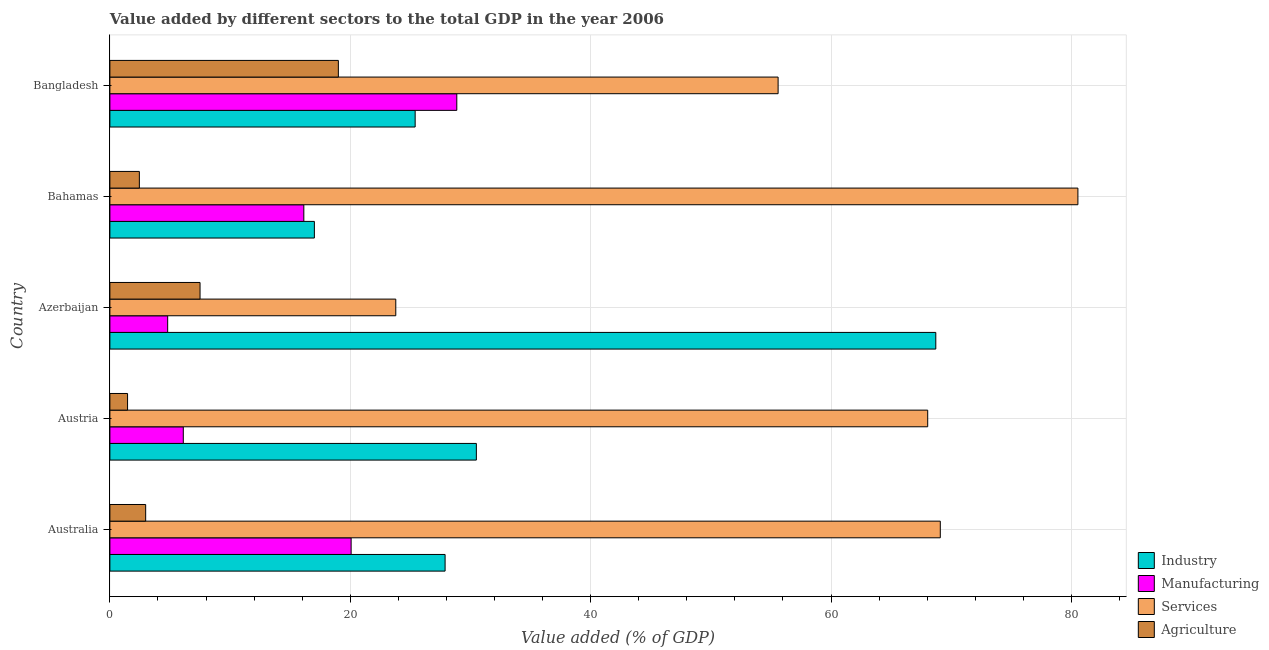How many different coloured bars are there?
Keep it short and to the point. 4. How many groups of bars are there?
Ensure brevity in your answer.  5. How many bars are there on the 4th tick from the top?
Provide a succinct answer. 4. In how many cases, is the number of bars for a given country not equal to the number of legend labels?
Your answer should be compact. 0. What is the value added by services sector in Azerbaijan?
Give a very brief answer. 23.79. Across all countries, what is the maximum value added by manufacturing sector?
Give a very brief answer. 28.86. Across all countries, what is the minimum value added by manufacturing sector?
Ensure brevity in your answer.  4.81. In which country was the value added by industrial sector maximum?
Your response must be concise. Azerbaijan. In which country was the value added by industrial sector minimum?
Offer a very short reply. Bahamas. What is the total value added by services sector in the graph?
Offer a very short reply. 297.04. What is the difference between the value added by services sector in Austria and that in Azerbaijan?
Offer a very short reply. 44.25. What is the difference between the value added by services sector in Australia and the value added by manufacturing sector in Austria?
Keep it short and to the point. 62.98. What is the average value added by agricultural sector per country?
Ensure brevity in your answer.  6.68. What is the difference between the value added by manufacturing sector and value added by services sector in Azerbaijan?
Your response must be concise. -18.98. What is the ratio of the value added by services sector in Australia to that in Azerbaijan?
Offer a terse response. 2.9. Is the difference between the value added by services sector in Australia and Azerbaijan greater than the difference between the value added by manufacturing sector in Australia and Azerbaijan?
Ensure brevity in your answer.  Yes. What is the difference between the highest and the second highest value added by industrial sector?
Provide a short and direct response. 38.22. What is the difference between the highest and the lowest value added by manufacturing sector?
Keep it short and to the point. 24.05. In how many countries, is the value added by agricultural sector greater than the average value added by agricultural sector taken over all countries?
Ensure brevity in your answer.  2. What does the 1st bar from the top in Bahamas represents?
Ensure brevity in your answer.  Agriculture. What does the 3rd bar from the bottom in Australia represents?
Provide a succinct answer. Services. How many bars are there?
Provide a succinct answer. 20. Are all the bars in the graph horizontal?
Ensure brevity in your answer.  Yes. What is the difference between two consecutive major ticks on the X-axis?
Offer a very short reply. 20. How are the legend labels stacked?
Keep it short and to the point. Vertical. What is the title of the graph?
Offer a terse response. Value added by different sectors to the total GDP in the year 2006. What is the label or title of the X-axis?
Offer a very short reply. Value added (% of GDP). What is the Value added (% of GDP) in Industry in Australia?
Provide a short and direct response. 27.89. What is the Value added (% of GDP) of Manufacturing in Australia?
Make the answer very short. 20.07. What is the Value added (% of GDP) in Services in Australia?
Offer a very short reply. 69.09. What is the Value added (% of GDP) of Agriculture in Australia?
Make the answer very short. 2.98. What is the Value added (% of GDP) in Industry in Austria?
Offer a very short reply. 30.49. What is the Value added (% of GDP) of Manufacturing in Austria?
Keep it short and to the point. 6.11. What is the Value added (% of GDP) in Services in Austria?
Offer a terse response. 68.04. What is the Value added (% of GDP) of Agriculture in Austria?
Your answer should be very brief. 1.47. What is the Value added (% of GDP) of Industry in Azerbaijan?
Offer a very short reply. 68.71. What is the Value added (% of GDP) of Manufacturing in Azerbaijan?
Make the answer very short. 4.81. What is the Value added (% of GDP) of Services in Azerbaijan?
Ensure brevity in your answer.  23.79. What is the Value added (% of GDP) of Agriculture in Azerbaijan?
Your response must be concise. 7.5. What is the Value added (% of GDP) in Industry in Bahamas?
Offer a terse response. 17.01. What is the Value added (% of GDP) in Manufacturing in Bahamas?
Offer a terse response. 16.13. What is the Value added (% of GDP) of Services in Bahamas?
Your answer should be very brief. 80.54. What is the Value added (% of GDP) of Agriculture in Bahamas?
Your response must be concise. 2.45. What is the Value added (% of GDP) in Industry in Bangladesh?
Offer a terse response. 25.4. What is the Value added (% of GDP) of Manufacturing in Bangladesh?
Provide a succinct answer. 28.86. What is the Value added (% of GDP) of Services in Bangladesh?
Give a very brief answer. 55.59. What is the Value added (% of GDP) of Agriculture in Bangladesh?
Your answer should be very brief. 19.01. Across all countries, what is the maximum Value added (% of GDP) of Industry?
Offer a very short reply. 68.71. Across all countries, what is the maximum Value added (% of GDP) of Manufacturing?
Make the answer very short. 28.86. Across all countries, what is the maximum Value added (% of GDP) of Services?
Keep it short and to the point. 80.54. Across all countries, what is the maximum Value added (% of GDP) of Agriculture?
Provide a short and direct response. 19.01. Across all countries, what is the minimum Value added (% of GDP) of Industry?
Your answer should be very brief. 17.01. Across all countries, what is the minimum Value added (% of GDP) of Manufacturing?
Give a very brief answer. 4.81. Across all countries, what is the minimum Value added (% of GDP) of Services?
Your answer should be compact. 23.79. Across all countries, what is the minimum Value added (% of GDP) in Agriculture?
Offer a very short reply. 1.47. What is the total Value added (% of GDP) in Industry in the graph?
Offer a very short reply. 169.5. What is the total Value added (% of GDP) in Manufacturing in the graph?
Provide a short and direct response. 75.98. What is the total Value added (% of GDP) of Services in the graph?
Your answer should be compact. 297.04. What is the total Value added (% of GDP) in Agriculture in the graph?
Provide a succinct answer. 33.41. What is the difference between the Value added (% of GDP) in Industry in Australia and that in Austria?
Make the answer very short. -2.6. What is the difference between the Value added (% of GDP) in Manufacturing in Australia and that in Austria?
Keep it short and to the point. 13.96. What is the difference between the Value added (% of GDP) of Services in Australia and that in Austria?
Make the answer very short. 1.05. What is the difference between the Value added (% of GDP) of Agriculture in Australia and that in Austria?
Make the answer very short. 1.51. What is the difference between the Value added (% of GDP) of Industry in Australia and that in Azerbaijan?
Give a very brief answer. -40.83. What is the difference between the Value added (% of GDP) in Manufacturing in Australia and that in Azerbaijan?
Offer a terse response. 15.26. What is the difference between the Value added (% of GDP) in Services in Australia and that in Azerbaijan?
Ensure brevity in your answer.  45.3. What is the difference between the Value added (% of GDP) in Agriculture in Australia and that in Azerbaijan?
Make the answer very short. -4.52. What is the difference between the Value added (% of GDP) in Industry in Australia and that in Bahamas?
Offer a very short reply. 10.88. What is the difference between the Value added (% of GDP) of Manufacturing in Australia and that in Bahamas?
Provide a short and direct response. 3.94. What is the difference between the Value added (% of GDP) in Services in Australia and that in Bahamas?
Keep it short and to the point. -11.45. What is the difference between the Value added (% of GDP) of Agriculture in Australia and that in Bahamas?
Give a very brief answer. 0.52. What is the difference between the Value added (% of GDP) of Industry in Australia and that in Bangladesh?
Provide a succinct answer. 2.49. What is the difference between the Value added (% of GDP) of Manufacturing in Australia and that in Bangladesh?
Provide a succinct answer. -8.79. What is the difference between the Value added (% of GDP) of Services in Australia and that in Bangladesh?
Make the answer very short. 13.49. What is the difference between the Value added (% of GDP) of Agriculture in Australia and that in Bangladesh?
Your response must be concise. -16.03. What is the difference between the Value added (% of GDP) of Industry in Austria and that in Azerbaijan?
Give a very brief answer. -38.22. What is the difference between the Value added (% of GDP) of Manufacturing in Austria and that in Azerbaijan?
Ensure brevity in your answer.  1.3. What is the difference between the Value added (% of GDP) in Services in Austria and that in Azerbaijan?
Offer a very short reply. 44.25. What is the difference between the Value added (% of GDP) of Agriculture in Austria and that in Azerbaijan?
Your response must be concise. -6.03. What is the difference between the Value added (% of GDP) of Industry in Austria and that in Bahamas?
Your answer should be very brief. 13.48. What is the difference between the Value added (% of GDP) of Manufacturing in Austria and that in Bahamas?
Offer a terse response. -10.03. What is the difference between the Value added (% of GDP) in Services in Austria and that in Bahamas?
Make the answer very short. -12.5. What is the difference between the Value added (% of GDP) of Agriculture in Austria and that in Bahamas?
Your answer should be very brief. -0.98. What is the difference between the Value added (% of GDP) in Industry in Austria and that in Bangladesh?
Offer a very short reply. 5.09. What is the difference between the Value added (% of GDP) in Manufacturing in Austria and that in Bangladesh?
Offer a terse response. -22.75. What is the difference between the Value added (% of GDP) in Services in Austria and that in Bangladesh?
Your answer should be very brief. 12.45. What is the difference between the Value added (% of GDP) in Agriculture in Austria and that in Bangladesh?
Your response must be concise. -17.54. What is the difference between the Value added (% of GDP) in Industry in Azerbaijan and that in Bahamas?
Offer a very short reply. 51.7. What is the difference between the Value added (% of GDP) in Manufacturing in Azerbaijan and that in Bahamas?
Provide a short and direct response. -11.33. What is the difference between the Value added (% of GDP) in Services in Azerbaijan and that in Bahamas?
Your answer should be compact. -56.75. What is the difference between the Value added (% of GDP) of Agriculture in Azerbaijan and that in Bahamas?
Keep it short and to the point. 5.05. What is the difference between the Value added (% of GDP) of Industry in Azerbaijan and that in Bangladesh?
Your response must be concise. 43.32. What is the difference between the Value added (% of GDP) in Manufacturing in Azerbaijan and that in Bangladesh?
Give a very brief answer. -24.05. What is the difference between the Value added (% of GDP) of Services in Azerbaijan and that in Bangladesh?
Your response must be concise. -31.81. What is the difference between the Value added (% of GDP) of Agriculture in Azerbaijan and that in Bangladesh?
Keep it short and to the point. -11.51. What is the difference between the Value added (% of GDP) in Industry in Bahamas and that in Bangladesh?
Provide a succinct answer. -8.39. What is the difference between the Value added (% of GDP) of Manufacturing in Bahamas and that in Bangladesh?
Ensure brevity in your answer.  -12.73. What is the difference between the Value added (% of GDP) of Services in Bahamas and that in Bangladesh?
Offer a terse response. 24.94. What is the difference between the Value added (% of GDP) of Agriculture in Bahamas and that in Bangladesh?
Your answer should be compact. -16.56. What is the difference between the Value added (% of GDP) of Industry in Australia and the Value added (% of GDP) of Manufacturing in Austria?
Provide a short and direct response. 21.78. What is the difference between the Value added (% of GDP) of Industry in Australia and the Value added (% of GDP) of Services in Austria?
Offer a very short reply. -40.15. What is the difference between the Value added (% of GDP) in Industry in Australia and the Value added (% of GDP) in Agriculture in Austria?
Your response must be concise. 26.42. What is the difference between the Value added (% of GDP) of Manufacturing in Australia and the Value added (% of GDP) of Services in Austria?
Keep it short and to the point. -47.97. What is the difference between the Value added (% of GDP) in Manufacturing in Australia and the Value added (% of GDP) in Agriculture in Austria?
Provide a succinct answer. 18.6. What is the difference between the Value added (% of GDP) in Services in Australia and the Value added (% of GDP) in Agriculture in Austria?
Provide a succinct answer. 67.62. What is the difference between the Value added (% of GDP) of Industry in Australia and the Value added (% of GDP) of Manufacturing in Azerbaijan?
Offer a terse response. 23.08. What is the difference between the Value added (% of GDP) in Industry in Australia and the Value added (% of GDP) in Services in Azerbaijan?
Give a very brief answer. 4.1. What is the difference between the Value added (% of GDP) in Industry in Australia and the Value added (% of GDP) in Agriculture in Azerbaijan?
Offer a terse response. 20.39. What is the difference between the Value added (% of GDP) of Manufacturing in Australia and the Value added (% of GDP) of Services in Azerbaijan?
Keep it short and to the point. -3.72. What is the difference between the Value added (% of GDP) in Manufacturing in Australia and the Value added (% of GDP) in Agriculture in Azerbaijan?
Keep it short and to the point. 12.57. What is the difference between the Value added (% of GDP) in Services in Australia and the Value added (% of GDP) in Agriculture in Azerbaijan?
Offer a very short reply. 61.59. What is the difference between the Value added (% of GDP) in Industry in Australia and the Value added (% of GDP) in Manufacturing in Bahamas?
Provide a succinct answer. 11.75. What is the difference between the Value added (% of GDP) in Industry in Australia and the Value added (% of GDP) in Services in Bahamas?
Give a very brief answer. -52.65. What is the difference between the Value added (% of GDP) in Industry in Australia and the Value added (% of GDP) in Agriculture in Bahamas?
Your answer should be very brief. 25.44. What is the difference between the Value added (% of GDP) in Manufacturing in Australia and the Value added (% of GDP) in Services in Bahamas?
Provide a succinct answer. -60.47. What is the difference between the Value added (% of GDP) of Manufacturing in Australia and the Value added (% of GDP) of Agriculture in Bahamas?
Offer a very short reply. 17.62. What is the difference between the Value added (% of GDP) of Services in Australia and the Value added (% of GDP) of Agriculture in Bahamas?
Your answer should be very brief. 66.64. What is the difference between the Value added (% of GDP) in Industry in Australia and the Value added (% of GDP) in Manufacturing in Bangladesh?
Give a very brief answer. -0.97. What is the difference between the Value added (% of GDP) in Industry in Australia and the Value added (% of GDP) in Services in Bangladesh?
Your answer should be very brief. -27.71. What is the difference between the Value added (% of GDP) in Industry in Australia and the Value added (% of GDP) in Agriculture in Bangladesh?
Keep it short and to the point. 8.88. What is the difference between the Value added (% of GDP) in Manufacturing in Australia and the Value added (% of GDP) in Services in Bangladesh?
Your answer should be very brief. -35.52. What is the difference between the Value added (% of GDP) in Manufacturing in Australia and the Value added (% of GDP) in Agriculture in Bangladesh?
Ensure brevity in your answer.  1.06. What is the difference between the Value added (% of GDP) of Services in Australia and the Value added (% of GDP) of Agriculture in Bangladesh?
Your answer should be compact. 50.08. What is the difference between the Value added (% of GDP) of Industry in Austria and the Value added (% of GDP) of Manufacturing in Azerbaijan?
Offer a terse response. 25.68. What is the difference between the Value added (% of GDP) in Industry in Austria and the Value added (% of GDP) in Services in Azerbaijan?
Offer a terse response. 6.7. What is the difference between the Value added (% of GDP) of Industry in Austria and the Value added (% of GDP) of Agriculture in Azerbaijan?
Make the answer very short. 22.99. What is the difference between the Value added (% of GDP) in Manufacturing in Austria and the Value added (% of GDP) in Services in Azerbaijan?
Ensure brevity in your answer.  -17.68. What is the difference between the Value added (% of GDP) in Manufacturing in Austria and the Value added (% of GDP) in Agriculture in Azerbaijan?
Offer a terse response. -1.39. What is the difference between the Value added (% of GDP) in Services in Austria and the Value added (% of GDP) in Agriculture in Azerbaijan?
Offer a very short reply. 60.54. What is the difference between the Value added (% of GDP) of Industry in Austria and the Value added (% of GDP) of Manufacturing in Bahamas?
Your answer should be compact. 14.36. What is the difference between the Value added (% of GDP) in Industry in Austria and the Value added (% of GDP) in Services in Bahamas?
Your answer should be very brief. -50.05. What is the difference between the Value added (% of GDP) of Industry in Austria and the Value added (% of GDP) of Agriculture in Bahamas?
Ensure brevity in your answer.  28.04. What is the difference between the Value added (% of GDP) in Manufacturing in Austria and the Value added (% of GDP) in Services in Bahamas?
Keep it short and to the point. -74.43. What is the difference between the Value added (% of GDP) of Manufacturing in Austria and the Value added (% of GDP) of Agriculture in Bahamas?
Make the answer very short. 3.66. What is the difference between the Value added (% of GDP) in Services in Austria and the Value added (% of GDP) in Agriculture in Bahamas?
Ensure brevity in your answer.  65.59. What is the difference between the Value added (% of GDP) of Industry in Austria and the Value added (% of GDP) of Manufacturing in Bangladesh?
Your answer should be compact. 1.63. What is the difference between the Value added (% of GDP) of Industry in Austria and the Value added (% of GDP) of Services in Bangladesh?
Offer a very short reply. -25.1. What is the difference between the Value added (% of GDP) in Industry in Austria and the Value added (% of GDP) in Agriculture in Bangladesh?
Offer a very short reply. 11.48. What is the difference between the Value added (% of GDP) in Manufacturing in Austria and the Value added (% of GDP) in Services in Bangladesh?
Provide a short and direct response. -49.49. What is the difference between the Value added (% of GDP) in Manufacturing in Austria and the Value added (% of GDP) in Agriculture in Bangladesh?
Offer a very short reply. -12.9. What is the difference between the Value added (% of GDP) of Services in Austria and the Value added (% of GDP) of Agriculture in Bangladesh?
Offer a terse response. 49.03. What is the difference between the Value added (% of GDP) in Industry in Azerbaijan and the Value added (% of GDP) in Manufacturing in Bahamas?
Your answer should be very brief. 52.58. What is the difference between the Value added (% of GDP) in Industry in Azerbaijan and the Value added (% of GDP) in Services in Bahamas?
Give a very brief answer. -11.82. What is the difference between the Value added (% of GDP) in Industry in Azerbaijan and the Value added (% of GDP) in Agriculture in Bahamas?
Ensure brevity in your answer.  66.26. What is the difference between the Value added (% of GDP) in Manufacturing in Azerbaijan and the Value added (% of GDP) in Services in Bahamas?
Make the answer very short. -75.73. What is the difference between the Value added (% of GDP) in Manufacturing in Azerbaijan and the Value added (% of GDP) in Agriculture in Bahamas?
Your answer should be very brief. 2.36. What is the difference between the Value added (% of GDP) in Services in Azerbaijan and the Value added (% of GDP) in Agriculture in Bahamas?
Offer a very short reply. 21.33. What is the difference between the Value added (% of GDP) in Industry in Azerbaijan and the Value added (% of GDP) in Manufacturing in Bangladesh?
Your answer should be compact. 39.85. What is the difference between the Value added (% of GDP) of Industry in Azerbaijan and the Value added (% of GDP) of Services in Bangladesh?
Provide a succinct answer. 13.12. What is the difference between the Value added (% of GDP) in Industry in Azerbaijan and the Value added (% of GDP) in Agriculture in Bangladesh?
Your response must be concise. 49.7. What is the difference between the Value added (% of GDP) in Manufacturing in Azerbaijan and the Value added (% of GDP) in Services in Bangladesh?
Keep it short and to the point. -50.79. What is the difference between the Value added (% of GDP) in Manufacturing in Azerbaijan and the Value added (% of GDP) in Agriculture in Bangladesh?
Ensure brevity in your answer.  -14.2. What is the difference between the Value added (% of GDP) in Services in Azerbaijan and the Value added (% of GDP) in Agriculture in Bangladesh?
Offer a terse response. 4.78. What is the difference between the Value added (% of GDP) in Industry in Bahamas and the Value added (% of GDP) in Manufacturing in Bangladesh?
Provide a short and direct response. -11.85. What is the difference between the Value added (% of GDP) in Industry in Bahamas and the Value added (% of GDP) in Services in Bangladesh?
Give a very brief answer. -38.58. What is the difference between the Value added (% of GDP) in Industry in Bahamas and the Value added (% of GDP) in Agriculture in Bangladesh?
Keep it short and to the point. -2. What is the difference between the Value added (% of GDP) of Manufacturing in Bahamas and the Value added (% of GDP) of Services in Bangladesh?
Make the answer very short. -39.46. What is the difference between the Value added (% of GDP) of Manufacturing in Bahamas and the Value added (% of GDP) of Agriculture in Bangladesh?
Offer a very short reply. -2.87. What is the difference between the Value added (% of GDP) of Services in Bahamas and the Value added (% of GDP) of Agriculture in Bangladesh?
Keep it short and to the point. 61.53. What is the average Value added (% of GDP) in Industry per country?
Give a very brief answer. 33.9. What is the average Value added (% of GDP) in Manufacturing per country?
Make the answer very short. 15.2. What is the average Value added (% of GDP) in Services per country?
Give a very brief answer. 59.41. What is the average Value added (% of GDP) of Agriculture per country?
Offer a very short reply. 6.68. What is the difference between the Value added (% of GDP) of Industry and Value added (% of GDP) of Manufacturing in Australia?
Offer a very short reply. 7.82. What is the difference between the Value added (% of GDP) of Industry and Value added (% of GDP) of Services in Australia?
Your answer should be compact. -41.2. What is the difference between the Value added (% of GDP) of Industry and Value added (% of GDP) of Agriculture in Australia?
Offer a terse response. 24.91. What is the difference between the Value added (% of GDP) of Manufacturing and Value added (% of GDP) of Services in Australia?
Offer a terse response. -49.02. What is the difference between the Value added (% of GDP) of Manufacturing and Value added (% of GDP) of Agriculture in Australia?
Your response must be concise. 17.09. What is the difference between the Value added (% of GDP) in Services and Value added (% of GDP) in Agriculture in Australia?
Your response must be concise. 66.11. What is the difference between the Value added (% of GDP) in Industry and Value added (% of GDP) in Manufacturing in Austria?
Offer a terse response. 24.38. What is the difference between the Value added (% of GDP) in Industry and Value added (% of GDP) in Services in Austria?
Offer a very short reply. -37.55. What is the difference between the Value added (% of GDP) of Industry and Value added (% of GDP) of Agriculture in Austria?
Your answer should be compact. 29.02. What is the difference between the Value added (% of GDP) in Manufacturing and Value added (% of GDP) in Services in Austria?
Your answer should be very brief. -61.93. What is the difference between the Value added (% of GDP) of Manufacturing and Value added (% of GDP) of Agriculture in Austria?
Provide a succinct answer. 4.64. What is the difference between the Value added (% of GDP) in Services and Value added (% of GDP) in Agriculture in Austria?
Your response must be concise. 66.57. What is the difference between the Value added (% of GDP) of Industry and Value added (% of GDP) of Manufacturing in Azerbaijan?
Give a very brief answer. 63.91. What is the difference between the Value added (% of GDP) in Industry and Value added (% of GDP) in Services in Azerbaijan?
Ensure brevity in your answer.  44.93. What is the difference between the Value added (% of GDP) in Industry and Value added (% of GDP) in Agriculture in Azerbaijan?
Your answer should be very brief. 61.21. What is the difference between the Value added (% of GDP) in Manufacturing and Value added (% of GDP) in Services in Azerbaijan?
Keep it short and to the point. -18.98. What is the difference between the Value added (% of GDP) of Manufacturing and Value added (% of GDP) of Agriculture in Azerbaijan?
Give a very brief answer. -2.69. What is the difference between the Value added (% of GDP) of Services and Value added (% of GDP) of Agriculture in Azerbaijan?
Your answer should be compact. 16.29. What is the difference between the Value added (% of GDP) of Industry and Value added (% of GDP) of Manufacturing in Bahamas?
Your answer should be compact. 0.88. What is the difference between the Value added (% of GDP) of Industry and Value added (% of GDP) of Services in Bahamas?
Make the answer very short. -63.52. What is the difference between the Value added (% of GDP) in Industry and Value added (% of GDP) in Agriculture in Bahamas?
Provide a succinct answer. 14.56. What is the difference between the Value added (% of GDP) of Manufacturing and Value added (% of GDP) of Services in Bahamas?
Make the answer very short. -64.4. What is the difference between the Value added (% of GDP) of Manufacturing and Value added (% of GDP) of Agriculture in Bahamas?
Provide a succinct answer. 13.68. What is the difference between the Value added (% of GDP) of Services and Value added (% of GDP) of Agriculture in Bahamas?
Make the answer very short. 78.08. What is the difference between the Value added (% of GDP) of Industry and Value added (% of GDP) of Manufacturing in Bangladesh?
Provide a succinct answer. -3.46. What is the difference between the Value added (% of GDP) in Industry and Value added (% of GDP) in Services in Bangladesh?
Ensure brevity in your answer.  -30.2. What is the difference between the Value added (% of GDP) of Industry and Value added (% of GDP) of Agriculture in Bangladesh?
Ensure brevity in your answer.  6.39. What is the difference between the Value added (% of GDP) of Manufacturing and Value added (% of GDP) of Services in Bangladesh?
Your answer should be compact. -26.73. What is the difference between the Value added (% of GDP) in Manufacturing and Value added (% of GDP) in Agriculture in Bangladesh?
Provide a short and direct response. 9.85. What is the difference between the Value added (% of GDP) in Services and Value added (% of GDP) in Agriculture in Bangladesh?
Your answer should be very brief. 36.59. What is the ratio of the Value added (% of GDP) in Industry in Australia to that in Austria?
Provide a succinct answer. 0.91. What is the ratio of the Value added (% of GDP) in Manufacturing in Australia to that in Austria?
Your answer should be compact. 3.29. What is the ratio of the Value added (% of GDP) of Services in Australia to that in Austria?
Offer a terse response. 1.02. What is the ratio of the Value added (% of GDP) in Agriculture in Australia to that in Austria?
Your response must be concise. 2.02. What is the ratio of the Value added (% of GDP) in Industry in Australia to that in Azerbaijan?
Keep it short and to the point. 0.41. What is the ratio of the Value added (% of GDP) in Manufacturing in Australia to that in Azerbaijan?
Provide a succinct answer. 4.17. What is the ratio of the Value added (% of GDP) of Services in Australia to that in Azerbaijan?
Offer a very short reply. 2.9. What is the ratio of the Value added (% of GDP) of Agriculture in Australia to that in Azerbaijan?
Provide a succinct answer. 0.4. What is the ratio of the Value added (% of GDP) of Industry in Australia to that in Bahamas?
Give a very brief answer. 1.64. What is the ratio of the Value added (% of GDP) in Manufacturing in Australia to that in Bahamas?
Provide a short and direct response. 1.24. What is the ratio of the Value added (% of GDP) in Services in Australia to that in Bahamas?
Offer a very short reply. 0.86. What is the ratio of the Value added (% of GDP) in Agriculture in Australia to that in Bahamas?
Keep it short and to the point. 1.21. What is the ratio of the Value added (% of GDP) in Industry in Australia to that in Bangladesh?
Provide a short and direct response. 1.1. What is the ratio of the Value added (% of GDP) of Manufacturing in Australia to that in Bangladesh?
Provide a succinct answer. 0.7. What is the ratio of the Value added (% of GDP) of Services in Australia to that in Bangladesh?
Provide a succinct answer. 1.24. What is the ratio of the Value added (% of GDP) of Agriculture in Australia to that in Bangladesh?
Offer a terse response. 0.16. What is the ratio of the Value added (% of GDP) in Industry in Austria to that in Azerbaijan?
Give a very brief answer. 0.44. What is the ratio of the Value added (% of GDP) in Manufacturing in Austria to that in Azerbaijan?
Ensure brevity in your answer.  1.27. What is the ratio of the Value added (% of GDP) in Services in Austria to that in Azerbaijan?
Your response must be concise. 2.86. What is the ratio of the Value added (% of GDP) in Agriculture in Austria to that in Azerbaijan?
Your answer should be very brief. 0.2. What is the ratio of the Value added (% of GDP) in Industry in Austria to that in Bahamas?
Offer a terse response. 1.79. What is the ratio of the Value added (% of GDP) of Manufacturing in Austria to that in Bahamas?
Your response must be concise. 0.38. What is the ratio of the Value added (% of GDP) of Services in Austria to that in Bahamas?
Your response must be concise. 0.84. What is the ratio of the Value added (% of GDP) in Agriculture in Austria to that in Bahamas?
Ensure brevity in your answer.  0.6. What is the ratio of the Value added (% of GDP) of Industry in Austria to that in Bangladesh?
Offer a very short reply. 1.2. What is the ratio of the Value added (% of GDP) of Manufacturing in Austria to that in Bangladesh?
Offer a terse response. 0.21. What is the ratio of the Value added (% of GDP) of Services in Austria to that in Bangladesh?
Provide a succinct answer. 1.22. What is the ratio of the Value added (% of GDP) in Agriculture in Austria to that in Bangladesh?
Provide a succinct answer. 0.08. What is the ratio of the Value added (% of GDP) of Industry in Azerbaijan to that in Bahamas?
Keep it short and to the point. 4.04. What is the ratio of the Value added (% of GDP) in Manufacturing in Azerbaijan to that in Bahamas?
Provide a succinct answer. 0.3. What is the ratio of the Value added (% of GDP) of Services in Azerbaijan to that in Bahamas?
Provide a succinct answer. 0.3. What is the ratio of the Value added (% of GDP) of Agriculture in Azerbaijan to that in Bahamas?
Provide a succinct answer. 3.06. What is the ratio of the Value added (% of GDP) of Industry in Azerbaijan to that in Bangladesh?
Keep it short and to the point. 2.71. What is the ratio of the Value added (% of GDP) of Manufacturing in Azerbaijan to that in Bangladesh?
Provide a short and direct response. 0.17. What is the ratio of the Value added (% of GDP) in Services in Azerbaijan to that in Bangladesh?
Keep it short and to the point. 0.43. What is the ratio of the Value added (% of GDP) in Agriculture in Azerbaijan to that in Bangladesh?
Provide a succinct answer. 0.39. What is the ratio of the Value added (% of GDP) of Industry in Bahamas to that in Bangladesh?
Keep it short and to the point. 0.67. What is the ratio of the Value added (% of GDP) of Manufacturing in Bahamas to that in Bangladesh?
Make the answer very short. 0.56. What is the ratio of the Value added (% of GDP) of Services in Bahamas to that in Bangladesh?
Your answer should be compact. 1.45. What is the ratio of the Value added (% of GDP) in Agriculture in Bahamas to that in Bangladesh?
Ensure brevity in your answer.  0.13. What is the difference between the highest and the second highest Value added (% of GDP) in Industry?
Your response must be concise. 38.22. What is the difference between the highest and the second highest Value added (% of GDP) of Manufacturing?
Keep it short and to the point. 8.79. What is the difference between the highest and the second highest Value added (% of GDP) in Services?
Your answer should be compact. 11.45. What is the difference between the highest and the second highest Value added (% of GDP) in Agriculture?
Offer a terse response. 11.51. What is the difference between the highest and the lowest Value added (% of GDP) of Industry?
Ensure brevity in your answer.  51.7. What is the difference between the highest and the lowest Value added (% of GDP) of Manufacturing?
Offer a terse response. 24.05. What is the difference between the highest and the lowest Value added (% of GDP) in Services?
Offer a very short reply. 56.75. What is the difference between the highest and the lowest Value added (% of GDP) in Agriculture?
Your answer should be very brief. 17.54. 